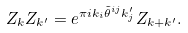Convert formula to latex. <formula><loc_0><loc_0><loc_500><loc_500>Z _ { k } Z _ { k ^ { \prime } } = e ^ { \pi i k _ { i } \tilde { \theta } ^ { i j } k _ { j } ^ { \prime } } Z _ { k + k ^ { \prime } } .</formula> 